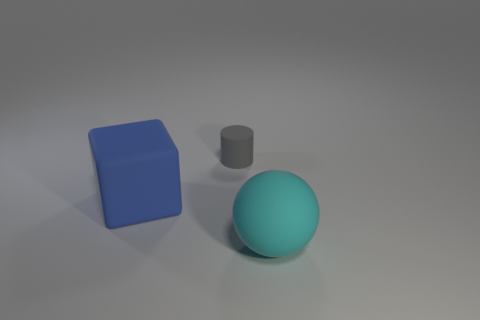Add 2 blue blocks. How many objects exist? 5 Subtract all cubes. How many objects are left? 2 Add 3 big red cubes. How many big red cubes exist? 3 Subtract 0 gray spheres. How many objects are left? 3 Subtract all small red metal things. Subtract all small cylinders. How many objects are left? 2 Add 3 tiny gray things. How many tiny gray things are left? 4 